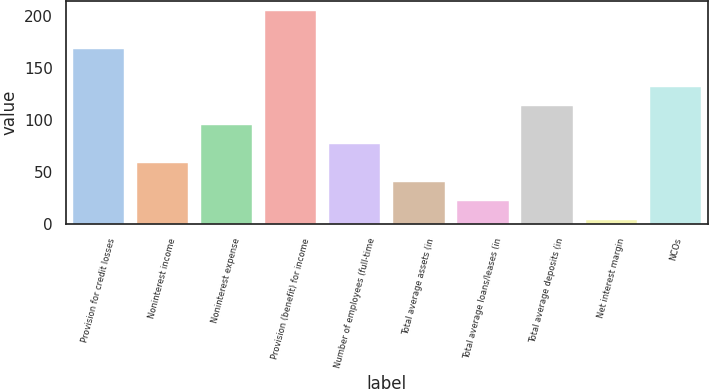<chart> <loc_0><loc_0><loc_500><loc_500><bar_chart><fcel>Provision for credit losses<fcel>Noninterest income<fcel>Noninterest expense<fcel>Provision (benefit) for income<fcel>Number of employees (full-time<fcel>Total average assets (in<fcel>Total average loans/leases (in<fcel>Total average deposits (in<fcel>Net interest margin<fcel>NCOs<nl><fcel>167.8<fcel>58.6<fcel>95<fcel>204.2<fcel>76.8<fcel>40.4<fcel>22.2<fcel>113.2<fcel>4<fcel>131.4<nl></chart> 